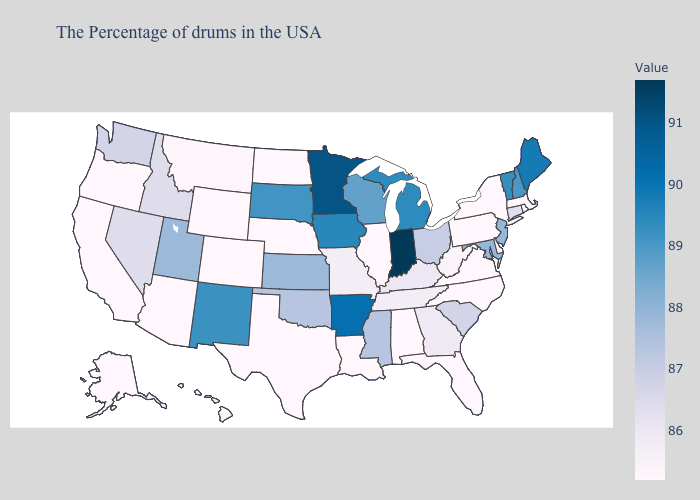Among the states that border Colorado , which have the lowest value?
Be succinct. Nebraska, Wyoming, Arizona. Does Indiana have the highest value in the USA?
Answer briefly. Yes. Does New Hampshire have the lowest value in the USA?
Be succinct. No. Which states have the lowest value in the Northeast?
Answer briefly. Massachusetts, Rhode Island, New York, Pennsylvania. Which states have the highest value in the USA?
Answer briefly. Indiana. 